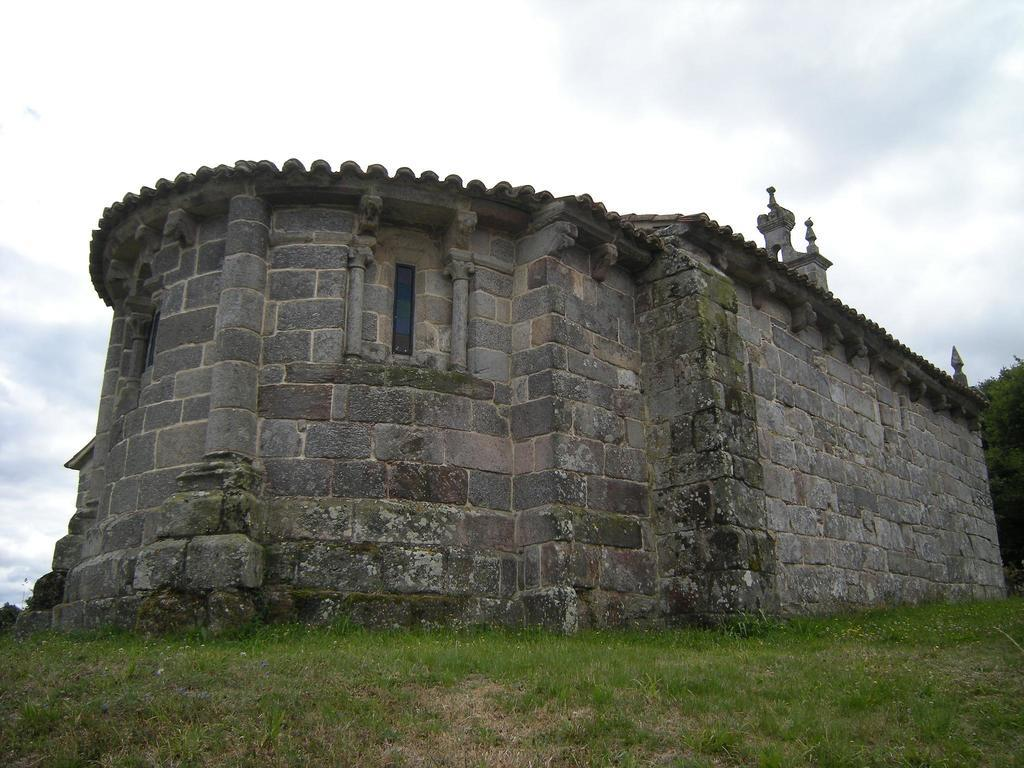What type of structure is visible in the image? There is a building with windows in the image. What type of vegetation can be seen in the image? There is grass and trees in the image. What is visible in the background of the image? The sky is visible in the background of the image. What can be observed in the sky? Clouds are present in the sky. How many children are playing on the roof of the building in the image? There are no children present in the image, and the roof of the building is not visible. 